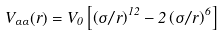<formula> <loc_0><loc_0><loc_500><loc_500>V _ { \alpha \alpha } ( r ) = V _ { 0 } \left [ \left ( \sigma / r \right ) ^ { 1 2 } - 2 \left ( \sigma / r \right ) ^ { 6 } \right ]</formula> 